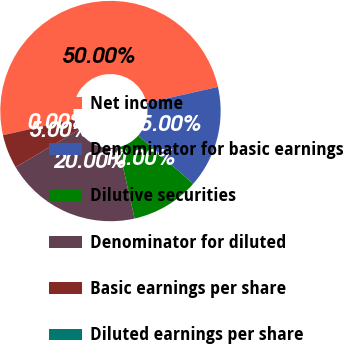Convert chart. <chart><loc_0><loc_0><loc_500><loc_500><pie_chart><fcel>Net income<fcel>Denominator for basic earnings<fcel>Dilutive securities<fcel>Denominator for diluted<fcel>Basic earnings per share<fcel>Diluted earnings per share<nl><fcel>50.0%<fcel>15.0%<fcel>10.0%<fcel>20.0%<fcel>5.0%<fcel>0.0%<nl></chart> 